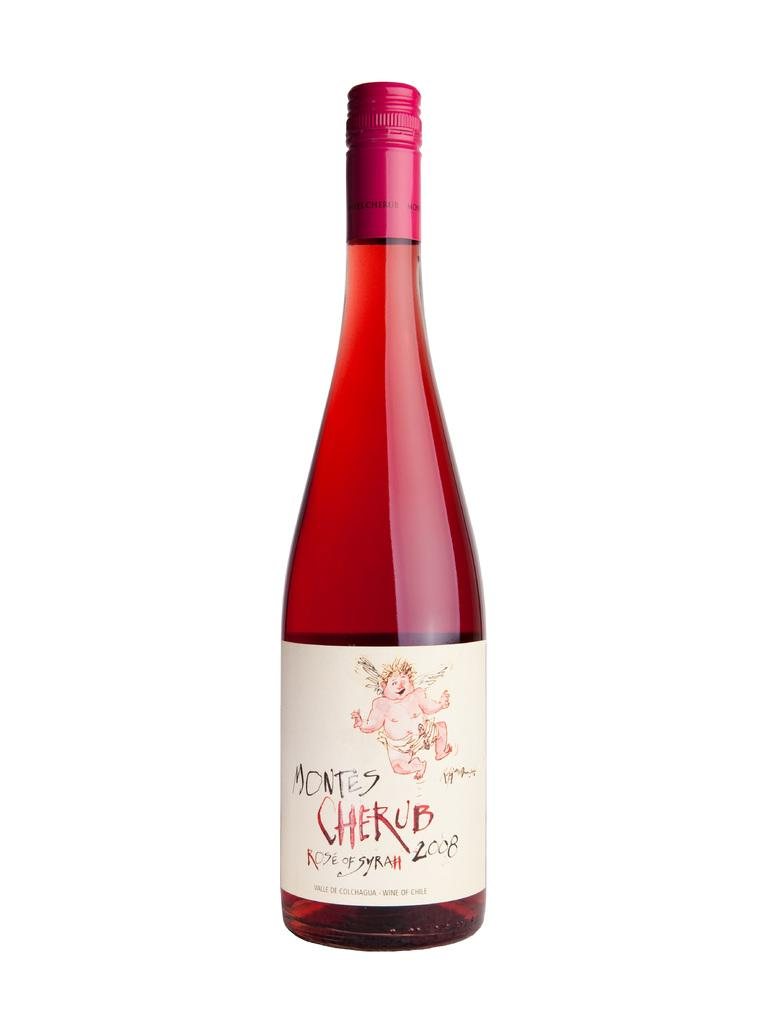What object is present in the image that contains a drink? There is a glass bottle in the image that contains a drink. What is the current state of the drink in the bottle? The drink is sealed in the bottle. What color is the background of the image? The background of the image is white. How many ducks are swimming in the drink inside the bottle? There are no ducks present in the image, and the drink is sealed inside the bottle. What type of bead is used to seal the drink in the bottle? The provided facts do not mention any specific type of bead used to seal the drink in the bottle. 